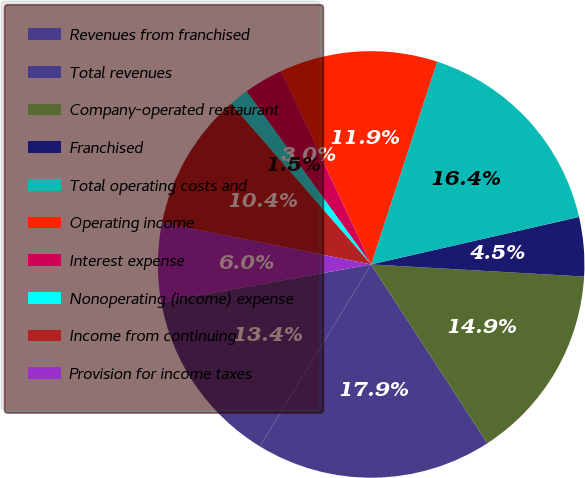Convert chart to OTSL. <chart><loc_0><loc_0><loc_500><loc_500><pie_chart><fcel>Revenues from franchised<fcel>Total revenues<fcel>Company-operated restaurant<fcel>Franchised<fcel>Total operating costs and<fcel>Operating income<fcel>Interest expense<fcel>Nonoperating (income) expense<fcel>Income from continuing<fcel>Provision for income taxes<nl><fcel>13.43%<fcel>17.91%<fcel>14.92%<fcel>4.48%<fcel>16.42%<fcel>11.94%<fcel>2.99%<fcel>1.49%<fcel>10.45%<fcel>5.97%<nl></chart> 